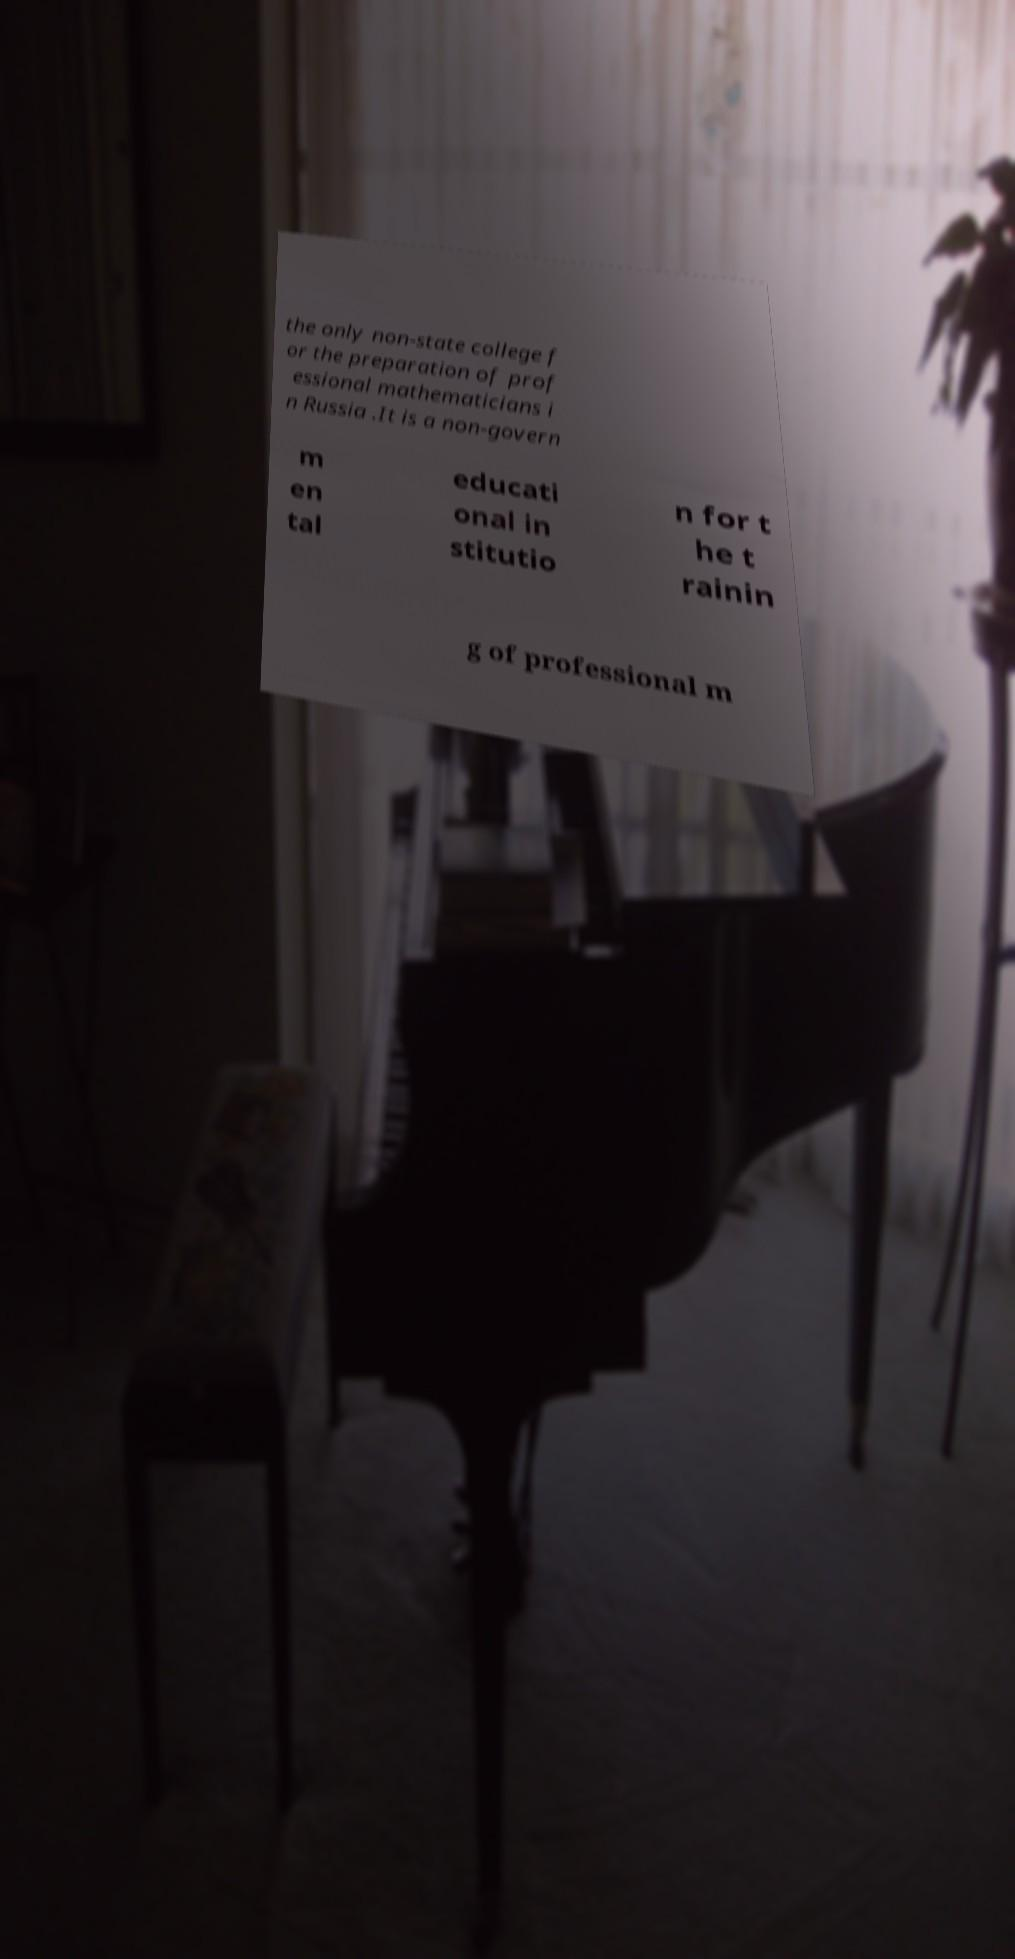For documentation purposes, I need the text within this image transcribed. Could you provide that? the only non-state college f or the preparation of prof essional mathematicians i n Russia .It is a non-govern m en tal educati onal in stitutio n for t he t rainin g of professional m 